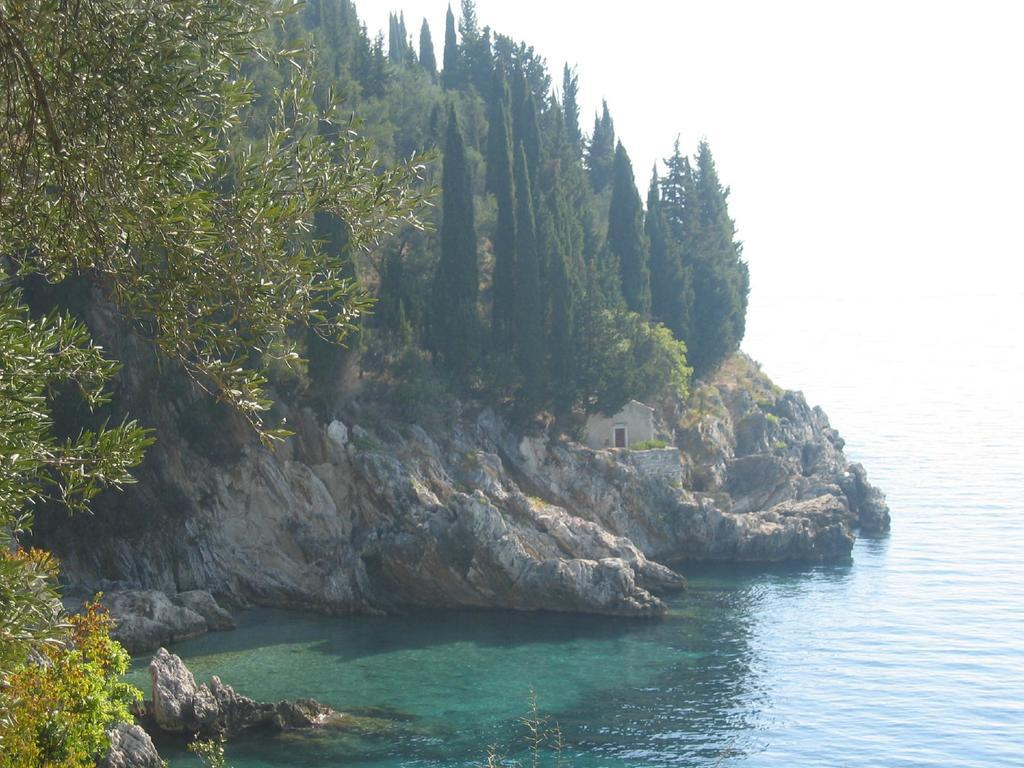What can be seen in the sky in the image? The sky is visible in the image. What type of vegetation is present in the image? There are trees in the image. What is the body of water in the image? There is water in the image. What type of structure is in the image? There is a house in the image. What geographical feature is present in the image? There is a hill in the image. Can you see a frog sitting on the roof of the house in the image? There is no frog present on the roof of the house in the image. What type of love is being expressed by the trees in the image? The trees in the image are not expressing any type of love; they are simply trees. 